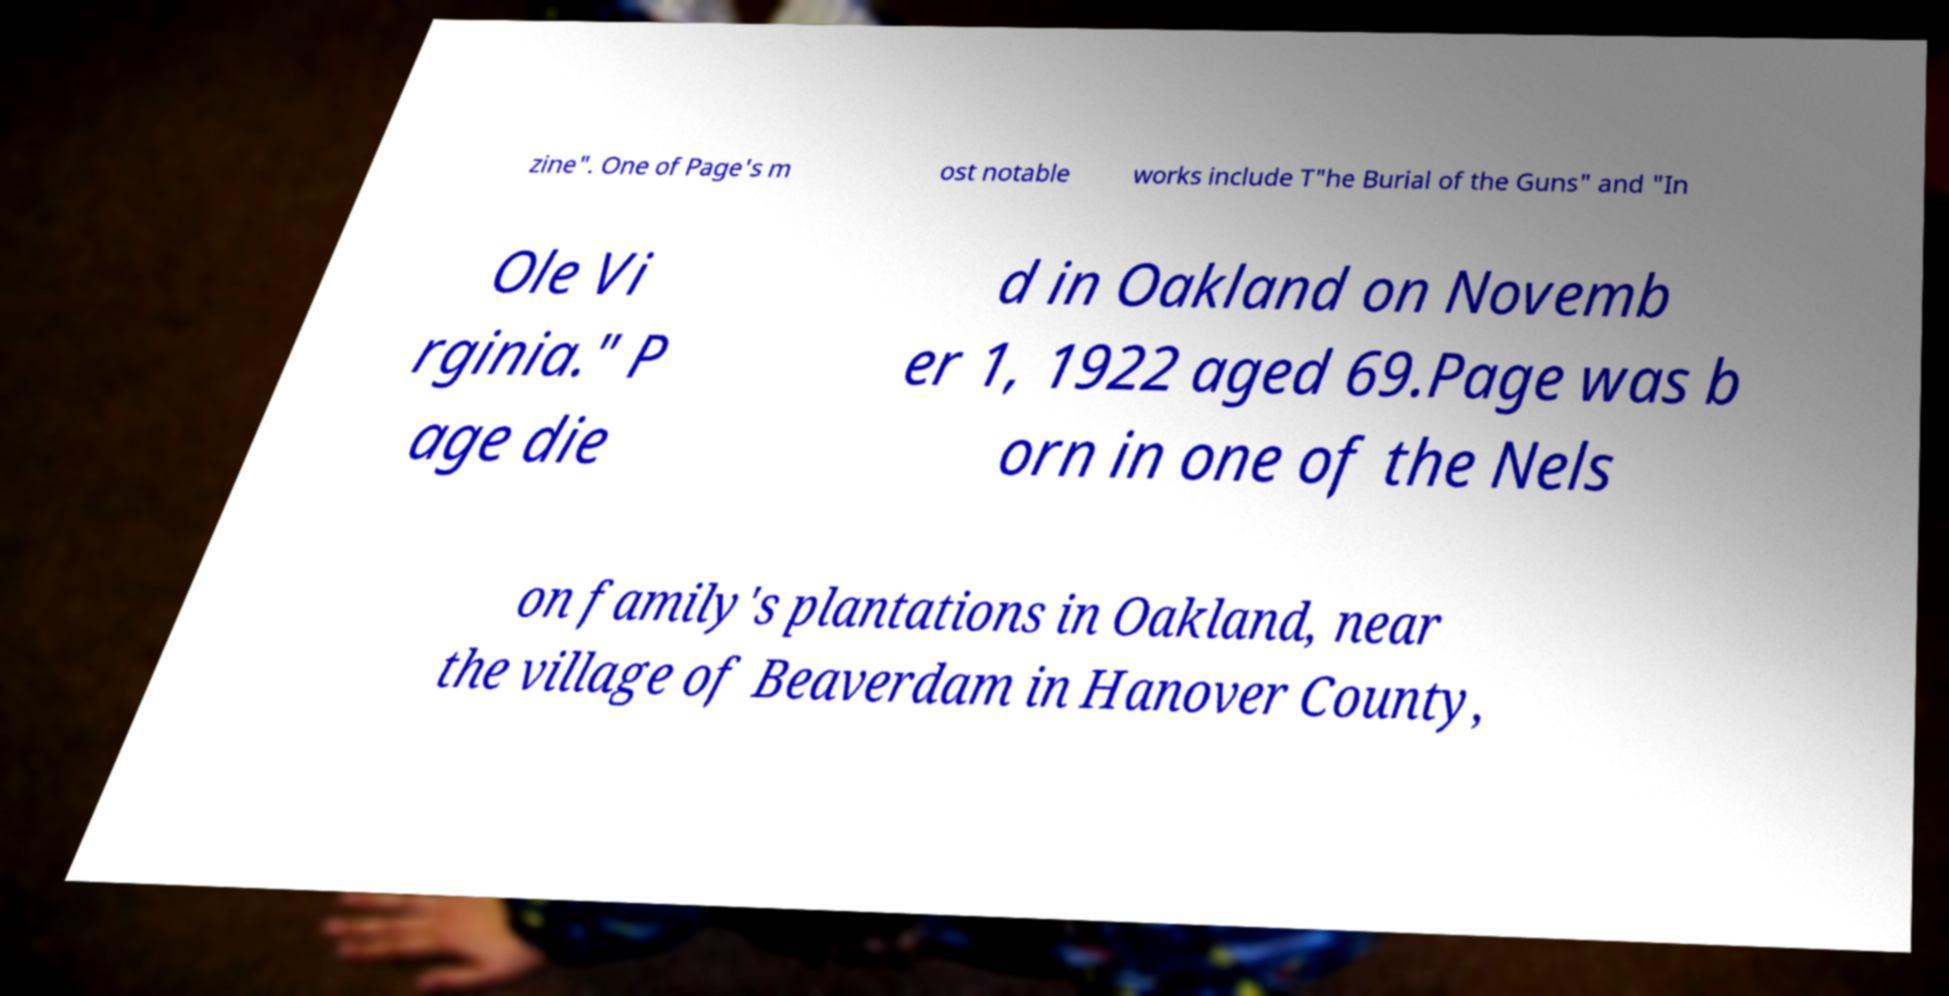Can you accurately transcribe the text from the provided image for me? zine". One of Page's m ost notable works include T"he Burial of the Guns" and "In Ole Vi rginia." P age die d in Oakland on Novemb er 1, 1922 aged 69.Page was b orn in one of the Nels on family's plantations in Oakland, near the village of Beaverdam in Hanover County, 